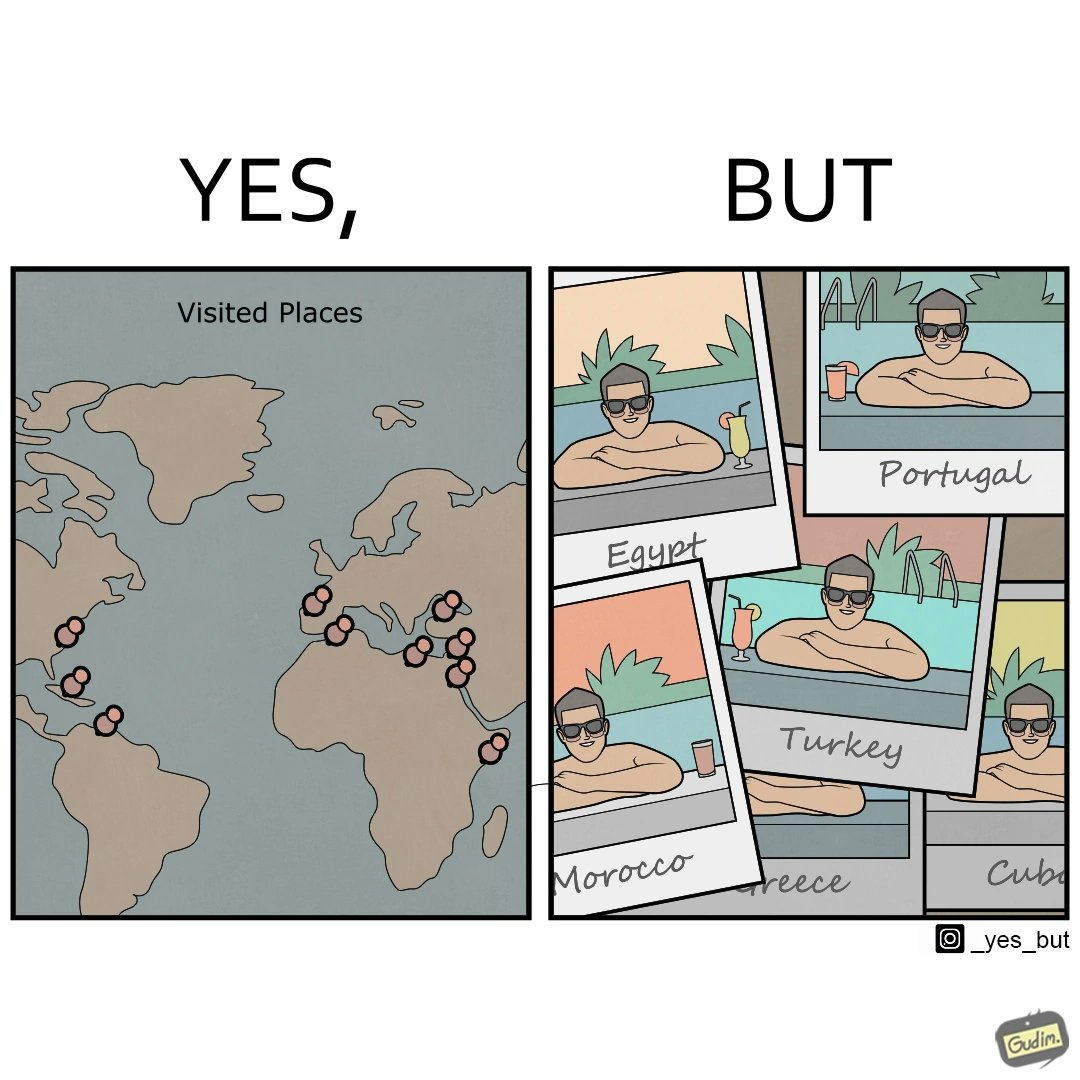What is shown in the left half versus the right half of this image? In the left part of the image: The image shows a map with pins set on places which have been visited by a person. In the right part of the image: The image shows several photos of a man wearing sunglasses  inside a pool in various countries like Egypt, Portugal, Morocco, Turkey, Greece and Cuba. 